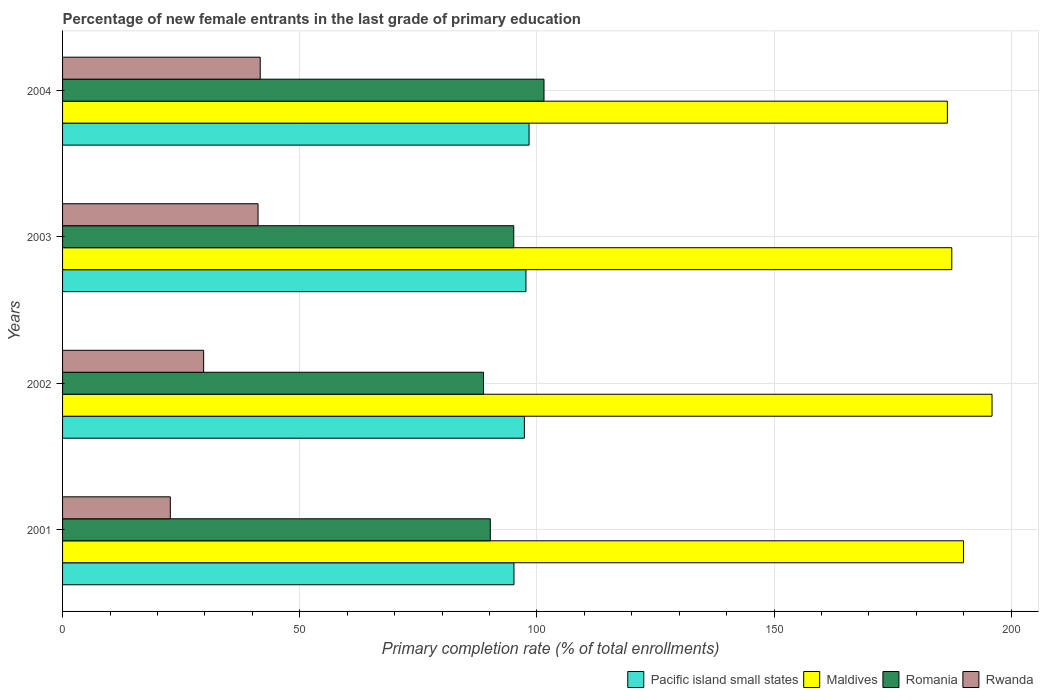How many groups of bars are there?
Give a very brief answer. 4. Are the number of bars per tick equal to the number of legend labels?
Your answer should be very brief. Yes. In how many cases, is the number of bars for a given year not equal to the number of legend labels?
Provide a succinct answer. 0. What is the percentage of new female entrants in Romania in 2004?
Give a very brief answer. 101.49. Across all years, what is the maximum percentage of new female entrants in Rwanda?
Your answer should be compact. 41.67. Across all years, what is the minimum percentage of new female entrants in Pacific island small states?
Your response must be concise. 95.16. In which year was the percentage of new female entrants in Maldives maximum?
Offer a very short reply. 2002. What is the total percentage of new female entrants in Rwanda in the graph?
Offer a terse response. 135.34. What is the difference between the percentage of new female entrants in Maldives in 2001 and that in 2004?
Provide a succinct answer. 3.4. What is the difference between the percentage of new female entrants in Maldives in 2004 and the percentage of new female entrants in Pacific island small states in 2002?
Your answer should be compact. 89.17. What is the average percentage of new female entrants in Romania per year?
Provide a short and direct response. 93.88. In the year 2003, what is the difference between the percentage of new female entrants in Maldives and percentage of new female entrants in Pacific island small states?
Provide a short and direct response. 89.77. What is the ratio of the percentage of new female entrants in Pacific island small states in 2001 to that in 2004?
Offer a very short reply. 0.97. Is the difference between the percentage of new female entrants in Maldives in 2002 and 2003 greater than the difference between the percentage of new female entrants in Pacific island small states in 2002 and 2003?
Your answer should be compact. Yes. What is the difference between the highest and the second highest percentage of new female entrants in Rwanda?
Provide a succinct answer. 0.46. What is the difference between the highest and the lowest percentage of new female entrants in Pacific island small states?
Ensure brevity in your answer.  3.18. Is the sum of the percentage of new female entrants in Pacific island small states in 2001 and 2003 greater than the maximum percentage of new female entrants in Romania across all years?
Make the answer very short. Yes. What does the 1st bar from the top in 2002 represents?
Provide a short and direct response. Rwanda. What does the 3rd bar from the bottom in 2003 represents?
Your answer should be compact. Romania. Is it the case that in every year, the sum of the percentage of new female entrants in Rwanda and percentage of new female entrants in Pacific island small states is greater than the percentage of new female entrants in Maldives?
Your response must be concise. No. How many years are there in the graph?
Provide a succinct answer. 4. Does the graph contain any zero values?
Ensure brevity in your answer.  No. How are the legend labels stacked?
Ensure brevity in your answer.  Horizontal. What is the title of the graph?
Your response must be concise. Percentage of new female entrants in the last grade of primary education. What is the label or title of the X-axis?
Offer a terse response. Primary completion rate (% of total enrollments). What is the label or title of the Y-axis?
Your response must be concise. Years. What is the Primary completion rate (% of total enrollments) of Pacific island small states in 2001?
Your response must be concise. 95.16. What is the Primary completion rate (% of total enrollments) in Maldives in 2001?
Keep it short and to the point. 189.93. What is the Primary completion rate (% of total enrollments) of Romania in 2001?
Offer a terse response. 90.17. What is the Primary completion rate (% of total enrollments) of Rwanda in 2001?
Ensure brevity in your answer.  22.72. What is the Primary completion rate (% of total enrollments) of Pacific island small states in 2002?
Your response must be concise. 97.36. What is the Primary completion rate (% of total enrollments) in Maldives in 2002?
Keep it short and to the point. 195.94. What is the Primary completion rate (% of total enrollments) of Romania in 2002?
Offer a terse response. 88.74. What is the Primary completion rate (% of total enrollments) in Rwanda in 2002?
Offer a very short reply. 29.74. What is the Primary completion rate (% of total enrollments) in Pacific island small states in 2003?
Provide a succinct answer. 97.69. What is the Primary completion rate (% of total enrollments) in Maldives in 2003?
Provide a short and direct response. 187.46. What is the Primary completion rate (% of total enrollments) of Romania in 2003?
Provide a succinct answer. 95.12. What is the Primary completion rate (% of total enrollments) of Rwanda in 2003?
Your response must be concise. 41.21. What is the Primary completion rate (% of total enrollments) in Pacific island small states in 2004?
Keep it short and to the point. 98.34. What is the Primary completion rate (% of total enrollments) of Maldives in 2004?
Provide a short and direct response. 186.52. What is the Primary completion rate (% of total enrollments) in Romania in 2004?
Your answer should be compact. 101.49. What is the Primary completion rate (% of total enrollments) of Rwanda in 2004?
Your response must be concise. 41.67. Across all years, what is the maximum Primary completion rate (% of total enrollments) in Pacific island small states?
Give a very brief answer. 98.34. Across all years, what is the maximum Primary completion rate (% of total enrollments) of Maldives?
Your answer should be very brief. 195.94. Across all years, what is the maximum Primary completion rate (% of total enrollments) in Romania?
Your answer should be very brief. 101.49. Across all years, what is the maximum Primary completion rate (% of total enrollments) of Rwanda?
Give a very brief answer. 41.67. Across all years, what is the minimum Primary completion rate (% of total enrollments) in Pacific island small states?
Give a very brief answer. 95.16. Across all years, what is the minimum Primary completion rate (% of total enrollments) in Maldives?
Make the answer very short. 186.52. Across all years, what is the minimum Primary completion rate (% of total enrollments) in Romania?
Make the answer very short. 88.74. Across all years, what is the minimum Primary completion rate (% of total enrollments) in Rwanda?
Provide a short and direct response. 22.72. What is the total Primary completion rate (% of total enrollments) in Pacific island small states in the graph?
Offer a terse response. 388.55. What is the total Primary completion rate (% of total enrollments) in Maldives in the graph?
Provide a succinct answer. 759.85. What is the total Primary completion rate (% of total enrollments) of Romania in the graph?
Provide a short and direct response. 375.52. What is the total Primary completion rate (% of total enrollments) in Rwanda in the graph?
Your answer should be very brief. 135.34. What is the difference between the Primary completion rate (% of total enrollments) in Pacific island small states in 2001 and that in 2002?
Give a very brief answer. -2.2. What is the difference between the Primary completion rate (% of total enrollments) in Maldives in 2001 and that in 2002?
Make the answer very short. -6.01. What is the difference between the Primary completion rate (% of total enrollments) in Romania in 2001 and that in 2002?
Provide a succinct answer. 1.44. What is the difference between the Primary completion rate (% of total enrollments) in Rwanda in 2001 and that in 2002?
Offer a terse response. -7.03. What is the difference between the Primary completion rate (% of total enrollments) of Pacific island small states in 2001 and that in 2003?
Offer a terse response. -2.53. What is the difference between the Primary completion rate (% of total enrollments) of Maldives in 2001 and that in 2003?
Your answer should be compact. 2.47. What is the difference between the Primary completion rate (% of total enrollments) of Romania in 2001 and that in 2003?
Provide a short and direct response. -4.94. What is the difference between the Primary completion rate (% of total enrollments) in Rwanda in 2001 and that in 2003?
Your answer should be very brief. -18.49. What is the difference between the Primary completion rate (% of total enrollments) in Pacific island small states in 2001 and that in 2004?
Offer a very short reply. -3.18. What is the difference between the Primary completion rate (% of total enrollments) in Maldives in 2001 and that in 2004?
Ensure brevity in your answer.  3.4. What is the difference between the Primary completion rate (% of total enrollments) in Romania in 2001 and that in 2004?
Provide a succinct answer. -11.32. What is the difference between the Primary completion rate (% of total enrollments) of Rwanda in 2001 and that in 2004?
Provide a succinct answer. -18.95. What is the difference between the Primary completion rate (% of total enrollments) in Pacific island small states in 2002 and that in 2003?
Your answer should be compact. -0.33. What is the difference between the Primary completion rate (% of total enrollments) of Maldives in 2002 and that in 2003?
Your answer should be compact. 8.48. What is the difference between the Primary completion rate (% of total enrollments) in Romania in 2002 and that in 2003?
Offer a terse response. -6.38. What is the difference between the Primary completion rate (% of total enrollments) in Rwanda in 2002 and that in 2003?
Your answer should be very brief. -11.47. What is the difference between the Primary completion rate (% of total enrollments) in Pacific island small states in 2002 and that in 2004?
Your response must be concise. -0.98. What is the difference between the Primary completion rate (% of total enrollments) in Maldives in 2002 and that in 2004?
Offer a very short reply. 9.42. What is the difference between the Primary completion rate (% of total enrollments) of Romania in 2002 and that in 2004?
Your response must be concise. -12.76. What is the difference between the Primary completion rate (% of total enrollments) of Rwanda in 2002 and that in 2004?
Your answer should be compact. -11.92. What is the difference between the Primary completion rate (% of total enrollments) in Pacific island small states in 2003 and that in 2004?
Make the answer very short. -0.65. What is the difference between the Primary completion rate (% of total enrollments) of Maldives in 2003 and that in 2004?
Provide a short and direct response. 0.93. What is the difference between the Primary completion rate (% of total enrollments) of Romania in 2003 and that in 2004?
Provide a short and direct response. -6.37. What is the difference between the Primary completion rate (% of total enrollments) of Rwanda in 2003 and that in 2004?
Your response must be concise. -0.46. What is the difference between the Primary completion rate (% of total enrollments) in Pacific island small states in 2001 and the Primary completion rate (% of total enrollments) in Maldives in 2002?
Give a very brief answer. -100.78. What is the difference between the Primary completion rate (% of total enrollments) in Pacific island small states in 2001 and the Primary completion rate (% of total enrollments) in Romania in 2002?
Ensure brevity in your answer.  6.42. What is the difference between the Primary completion rate (% of total enrollments) of Pacific island small states in 2001 and the Primary completion rate (% of total enrollments) of Rwanda in 2002?
Provide a succinct answer. 65.42. What is the difference between the Primary completion rate (% of total enrollments) of Maldives in 2001 and the Primary completion rate (% of total enrollments) of Romania in 2002?
Give a very brief answer. 101.19. What is the difference between the Primary completion rate (% of total enrollments) of Maldives in 2001 and the Primary completion rate (% of total enrollments) of Rwanda in 2002?
Ensure brevity in your answer.  160.18. What is the difference between the Primary completion rate (% of total enrollments) in Romania in 2001 and the Primary completion rate (% of total enrollments) in Rwanda in 2002?
Give a very brief answer. 60.43. What is the difference between the Primary completion rate (% of total enrollments) in Pacific island small states in 2001 and the Primary completion rate (% of total enrollments) in Maldives in 2003?
Offer a very short reply. -92.3. What is the difference between the Primary completion rate (% of total enrollments) in Pacific island small states in 2001 and the Primary completion rate (% of total enrollments) in Romania in 2003?
Make the answer very short. 0.04. What is the difference between the Primary completion rate (% of total enrollments) of Pacific island small states in 2001 and the Primary completion rate (% of total enrollments) of Rwanda in 2003?
Your answer should be compact. 53.95. What is the difference between the Primary completion rate (% of total enrollments) of Maldives in 2001 and the Primary completion rate (% of total enrollments) of Romania in 2003?
Give a very brief answer. 94.81. What is the difference between the Primary completion rate (% of total enrollments) of Maldives in 2001 and the Primary completion rate (% of total enrollments) of Rwanda in 2003?
Offer a very short reply. 148.72. What is the difference between the Primary completion rate (% of total enrollments) in Romania in 2001 and the Primary completion rate (% of total enrollments) in Rwanda in 2003?
Make the answer very short. 48.96. What is the difference between the Primary completion rate (% of total enrollments) in Pacific island small states in 2001 and the Primary completion rate (% of total enrollments) in Maldives in 2004?
Ensure brevity in your answer.  -91.36. What is the difference between the Primary completion rate (% of total enrollments) in Pacific island small states in 2001 and the Primary completion rate (% of total enrollments) in Romania in 2004?
Keep it short and to the point. -6.33. What is the difference between the Primary completion rate (% of total enrollments) in Pacific island small states in 2001 and the Primary completion rate (% of total enrollments) in Rwanda in 2004?
Ensure brevity in your answer.  53.49. What is the difference between the Primary completion rate (% of total enrollments) of Maldives in 2001 and the Primary completion rate (% of total enrollments) of Romania in 2004?
Provide a succinct answer. 88.43. What is the difference between the Primary completion rate (% of total enrollments) of Maldives in 2001 and the Primary completion rate (% of total enrollments) of Rwanda in 2004?
Ensure brevity in your answer.  148.26. What is the difference between the Primary completion rate (% of total enrollments) in Romania in 2001 and the Primary completion rate (% of total enrollments) in Rwanda in 2004?
Ensure brevity in your answer.  48.51. What is the difference between the Primary completion rate (% of total enrollments) in Pacific island small states in 2002 and the Primary completion rate (% of total enrollments) in Maldives in 2003?
Your answer should be very brief. -90.1. What is the difference between the Primary completion rate (% of total enrollments) in Pacific island small states in 2002 and the Primary completion rate (% of total enrollments) in Romania in 2003?
Your response must be concise. 2.24. What is the difference between the Primary completion rate (% of total enrollments) in Pacific island small states in 2002 and the Primary completion rate (% of total enrollments) in Rwanda in 2003?
Provide a succinct answer. 56.15. What is the difference between the Primary completion rate (% of total enrollments) in Maldives in 2002 and the Primary completion rate (% of total enrollments) in Romania in 2003?
Give a very brief answer. 100.82. What is the difference between the Primary completion rate (% of total enrollments) in Maldives in 2002 and the Primary completion rate (% of total enrollments) in Rwanda in 2003?
Provide a short and direct response. 154.73. What is the difference between the Primary completion rate (% of total enrollments) in Romania in 2002 and the Primary completion rate (% of total enrollments) in Rwanda in 2003?
Offer a terse response. 47.53. What is the difference between the Primary completion rate (% of total enrollments) in Pacific island small states in 2002 and the Primary completion rate (% of total enrollments) in Maldives in 2004?
Ensure brevity in your answer.  -89.17. What is the difference between the Primary completion rate (% of total enrollments) of Pacific island small states in 2002 and the Primary completion rate (% of total enrollments) of Romania in 2004?
Give a very brief answer. -4.14. What is the difference between the Primary completion rate (% of total enrollments) in Pacific island small states in 2002 and the Primary completion rate (% of total enrollments) in Rwanda in 2004?
Offer a terse response. 55.69. What is the difference between the Primary completion rate (% of total enrollments) in Maldives in 2002 and the Primary completion rate (% of total enrollments) in Romania in 2004?
Provide a succinct answer. 94.45. What is the difference between the Primary completion rate (% of total enrollments) in Maldives in 2002 and the Primary completion rate (% of total enrollments) in Rwanda in 2004?
Provide a short and direct response. 154.27. What is the difference between the Primary completion rate (% of total enrollments) of Romania in 2002 and the Primary completion rate (% of total enrollments) of Rwanda in 2004?
Offer a very short reply. 47.07. What is the difference between the Primary completion rate (% of total enrollments) of Pacific island small states in 2003 and the Primary completion rate (% of total enrollments) of Maldives in 2004?
Make the answer very short. -88.83. What is the difference between the Primary completion rate (% of total enrollments) in Pacific island small states in 2003 and the Primary completion rate (% of total enrollments) in Romania in 2004?
Provide a short and direct response. -3.8. What is the difference between the Primary completion rate (% of total enrollments) in Pacific island small states in 2003 and the Primary completion rate (% of total enrollments) in Rwanda in 2004?
Your answer should be compact. 56.02. What is the difference between the Primary completion rate (% of total enrollments) of Maldives in 2003 and the Primary completion rate (% of total enrollments) of Romania in 2004?
Ensure brevity in your answer.  85.96. What is the difference between the Primary completion rate (% of total enrollments) of Maldives in 2003 and the Primary completion rate (% of total enrollments) of Rwanda in 2004?
Make the answer very short. 145.79. What is the difference between the Primary completion rate (% of total enrollments) of Romania in 2003 and the Primary completion rate (% of total enrollments) of Rwanda in 2004?
Offer a very short reply. 53.45. What is the average Primary completion rate (% of total enrollments) in Pacific island small states per year?
Offer a terse response. 97.14. What is the average Primary completion rate (% of total enrollments) of Maldives per year?
Your response must be concise. 189.96. What is the average Primary completion rate (% of total enrollments) in Romania per year?
Offer a very short reply. 93.88. What is the average Primary completion rate (% of total enrollments) of Rwanda per year?
Keep it short and to the point. 33.83. In the year 2001, what is the difference between the Primary completion rate (% of total enrollments) of Pacific island small states and Primary completion rate (% of total enrollments) of Maldives?
Provide a short and direct response. -94.77. In the year 2001, what is the difference between the Primary completion rate (% of total enrollments) in Pacific island small states and Primary completion rate (% of total enrollments) in Romania?
Ensure brevity in your answer.  4.99. In the year 2001, what is the difference between the Primary completion rate (% of total enrollments) in Pacific island small states and Primary completion rate (% of total enrollments) in Rwanda?
Provide a short and direct response. 72.44. In the year 2001, what is the difference between the Primary completion rate (% of total enrollments) of Maldives and Primary completion rate (% of total enrollments) of Romania?
Your answer should be compact. 99.75. In the year 2001, what is the difference between the Primary completion rate (% of total enrollments) in Maldives and Primary completion rate (% of total enrollments) in Rwanda?
Your answer should be very brief. 167.21. In the year 2001, what is the difference between the Primary completion rate (% of total enrollments) of Romania and Primary completion rate (% of total enrollments) of Rwanda?
Make the answer very short. 67.46. In the year 2002, what is the difference between the Primary completion rate (% of total enrollments) of Pacific island small states and Primary completion rate (% of total enrollments) of Maldives?
Your answer should be very brief. -98.58. In the year 2002, what is the difference between the Primary completion rate (% of total enrollments) of Pacific island small states and Primary completion rate (% of total enrollments) of Romania?
Offer a terse response. 8.62. In the year 2002, what is the difference between the Primary completion rate (% of total enrollments) of Pacific island small states and Primary completion rate (% of total enrollments) of Rwanda?
Provide a succinct answer. 67.61. In the year 2002, what is the difference between the Primary completion rate (% of total enrollments) in Maldives and Primary completion rate (% of total enrollments) in Romania?
Offer a terse response. 107.2. In the year 2002, what is the difference between the Primary completion rate (% of total enrollments) in Maldives and Primary completion rate (% of total enrollments) in Rwanda?
Ensure brevity in your answer.  166.2. In the year 2002, what is the difference between the Primary completion rate (% of total enrollments) of Romania and Primary completion rate (% of total enrollments) of Rwanda?
Make the answer very short. 59. In the year 2003, what is the difference between the Primary completion rate (% of total enrollments) of Pacific island small states and Primary completion rate (% of total enrollments) of Maldives?
Offer a terse response. -89.77. In the year 2003, what is the difference between the Primary completion rate (% of total enrollments) in Pacific island small states and Primary completion rate (% of total enrollments) in Romania?
Give a very brief answer. 2.57. In the year 2003, what is the difference between the Primary completion rate (% of total enrollments) of Pacific island small states and Primary completion rate (% of total enrollments) of Rwanda?
Provide a succinct answer. 56.48. In the year 2003, what is the difference between the Primary completion rate (% of total enrollments) in Maldives and Primary completion rate (% of total enrollments) in Romania?
Your response must be concise. 92.34. In the year 2003, what is the difference between the Primary completion rate (% of total enrollments) of Maldives and Primary completion rate (% of total enrollments) of Rwanda?
Your answer should be very brief. 146.25. In the year 2003, what is the difference between the Primary completion rate (% of total enrollments) of Romania and Primary completion rate (% of total enrollments) of Rwanda?
Provide a succinct answer. 53.91. In the year 2004, what is the difference between the Primary completion rate (% of total enrollments) of Pacific island small states and Primary completion rate (% of total enrollments) of Maldives?
Your answer should be compact. -88.18. In the year 2004, what is the difference between the Primary completion rate (% of total enrollments) in Pacific island small states and Primary completion rate (% of total enrollments) in Romania?
Provide a succinct answer. -3.15. In the year 2004, what is the difference between the Primary completion rate (% of total enrollments) of Pacific island small states and Primary completion rate (% of total enrollments) of Rwanda?
Your response must be concise. 56.67. In the year 2004, what is the difference between the Primary completion rate (% of total enrollments) in Maldives and Primary completion rate (% of total enrollments) in Romania?
Offer a very short reply. 85.03. In the year 2004, what is the difference between the Primary completion rate (% of total enrollments) in Maldives and Primary completion rate (% of total enrollments) in Rwanda?
Ensure brevity in your answer.  144.86. In the year 2004, what is the difference between the Primary completion rate (% of total enrollments) in Romania and Primary completion rate (% of total enrollments) in Rwanda?
Make the answer very short. 59.83. What is the ratio of the Primary completion rate (% of total enrollments) in Pacific island small states in 2001 to that in 2002?
Offer a terse response. 0.98. What is the ratio of the Primary completion rate (% of total enrollments) in Maldives in 2001 to that in 2002?
Offer a very short reply. 0.97. What is the ratio of the Primary completion rate (% of total enrollments) of Romania in 2001 to that in 2002?
Provide a succinct answer. 1.02. What is the ratio of the Primary completion rate (% of total enrollments) of Rwanda in 2001 to that in 2002?
Offer a very short reply. 0.76. What is the ratio of the Primary completion rate (% of total enrollments) in Pacific island small states in 2001 to that in 2003?
Offer a very short reply. 0.97. What is the ratio of the Primary completion rate (% of total enrollments) of Maldives in 2001 to that in 2003?
Keep it short and to the point. 1.01. What is the ratio of the Primary completion rate (% of total enrollments) in Romania in 2001 to that in 2003?
Keep it short and to the point. 0.95. What is the ratio of the Primary completion rate (% of total enrollments) in Rwanda in 2001 to that in 2003?
Offer a terse response. 0.55. What is the ratio of the Primary completion rate (% of total enrollments) of Pacific island small states in 2001 to that in 2004?
Provide a succinct answer. 0.97. What is the ratio of the Primary completion rate (% of total enrollments) of Maldives in 2001 to that in 2004?
Ensure brevity in your answer.  1.02. What is the ratio of the Primary completion rate (% of total enrollments) in Romania in 2001 to that in 2004?
Ensure brevity in your answer.  0.89. What is the ratio of the Primary completion rate (% of total enrollments) of Rwanda in 2001 to that in 2004?
Give a very brief answer. 0.55. What is the ratio of the Primary completion rate (% of total enrollments) of Pacific island small states in 2002 to that in 2003?
Your answer should be compact. 1. What is the ratio of the Primary completion rate (% of total enrollments) of Maldives in 2002 to that in 2003?
Ensure brevity in your answer.  1.05. What is the ratio of the Primary completion rate (% of total enrollments) of Romania in 2002 to that in 2003?
Provide a succinct answer. 0.93. What is the ratio of the Primary completion rate (% of total enrollments) of Rwanda in 2002 to that in 2003?
Your answer should be compact. 0.72. What is the ratio of the Primary completion rate (% of total enrollments) in Maldives in 2002 to that in 2004?
Your answer should be compact. 1.05. What is the ratio of the Primary completion rate (% of total enrollments) of Romania in 2002 to that in 2004?
Provide a short and direct response. 0.87. What is the ratio of the Primary completion rate (% of total enrollments) in Rwanda in 2002 to that in 2004?
Provide a short and direct response. 0.71. What is the ratio of the Primary completion rate (% of total enrollments) in Romania in 2003 to that in 2004?
Keep it short and to the point. 0.94. What is the ratio of the Primary completion rate (% of total enrollments) in Rwanda in 2003 to that in 2004?
Your answer should be very brief. 0.99. What is the difference between the highest and the second highest Primary completion rate (% of total enrollments) in Pacific island small states?
Offer a very short reply. 0.65. What is the difference between the highest and the second highest Primary completion rate (% of total enrollments) of Maldives?
Offer a very short reply. 6.01. What is the difference between the highest and the second highest Primary completion rate (% of total enrollments) of Romania?
Make the answer very short. 6.37. What is the difference between the highest and the second highest Primary completion rate (% of total enrollments) of Rwanda?
Offer a terse response. 0.46. What is the difference between the highest and the lowest Primary completion rate (% of total enrollments) of Pacific island small states?
Give a very brief answer. 3.18. What is the difference between the highest and the lowest Primary completion rate (% of total enrollments) of Maldives?
Offer a terse response. 9.42. What is the difference between the highest and the lowest Primary completion rate (% of total enrollments) of Romania?
Provide a succinct answer. 12.76. What is the difference between the highest and the lowest Primary completion rate (% of total enrollments) of Rwanda?
Your response must be concise. 18.95. 